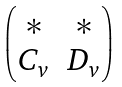<formula> <loc_0><loc_0><loc_500><loc_500>\begin{pmatrix} * & * \\ C _ { v } & D _ { v } \end{pmatrix}</formula> 